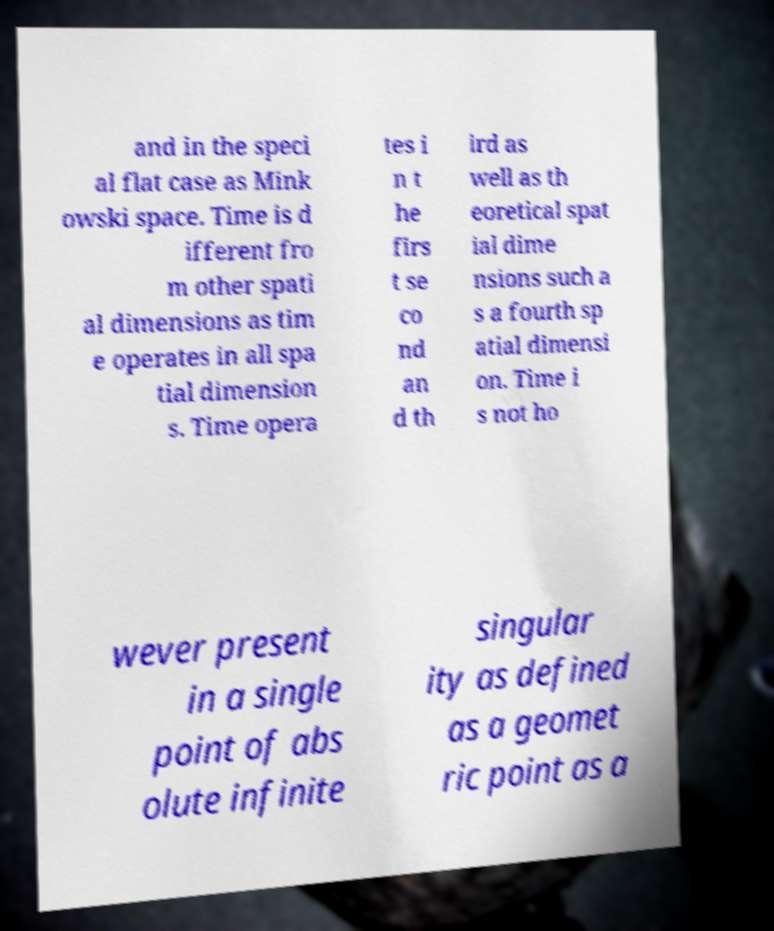Can you accurately transcribe the text from the provided image for me? and in the speci al flat case as Mink owski space. Time is d ifferent fro m other spati al dimensions as tim e operates in all spa tial dimension s. Time opera tes i n t he firs t se co nd an d th ird as well as th eoretical spat ial dime nsions such a s a fourth sp atial dimensi on. Time i s not ho wever present in a single point of abs olute infinite singular ity as defined as a geomet ric point as a 